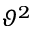<formula> <loc_0><loc_0><loc_500><loc_500>\vartheta ^ { 2 }</formula> 